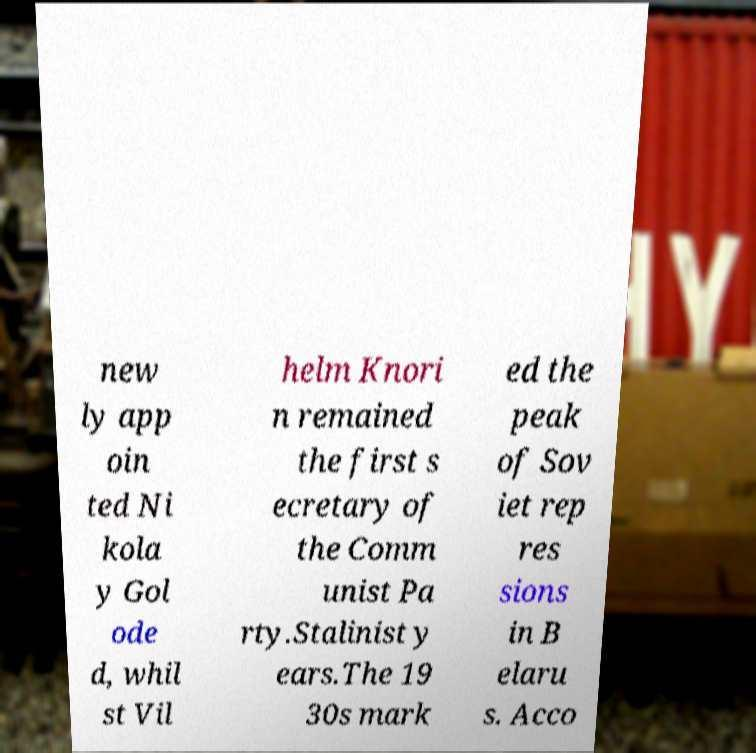What messages or text are displayed in this image? I need them in a readable, typed format. new ly app oin ted Ni kola y Gol ode d, whil st Vil helm Knori n remained the first s ecretary of the Comm unist Pa rty.Stalinist y ears.The 19 30s mark ed the peak of Sov iet rep res sions in B elaru s. Acco 